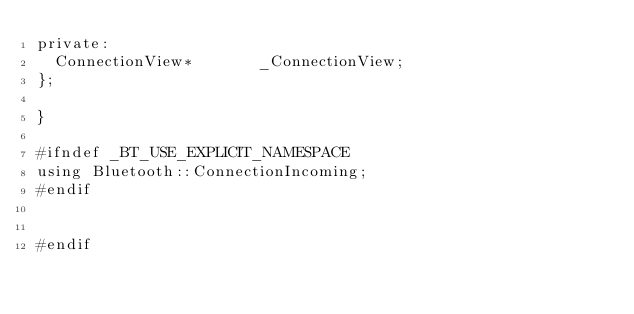<code> <loc_0><loc_0><loc_500><loc_500><_C_>private:
	ConnectionView*				_ConnectionView;
};

}

#ifndef _BT_USE_EXPLICIT_NAMESPACE
using Bluetooth::ConnectionIncoming;
#endif


#endif
</code> 